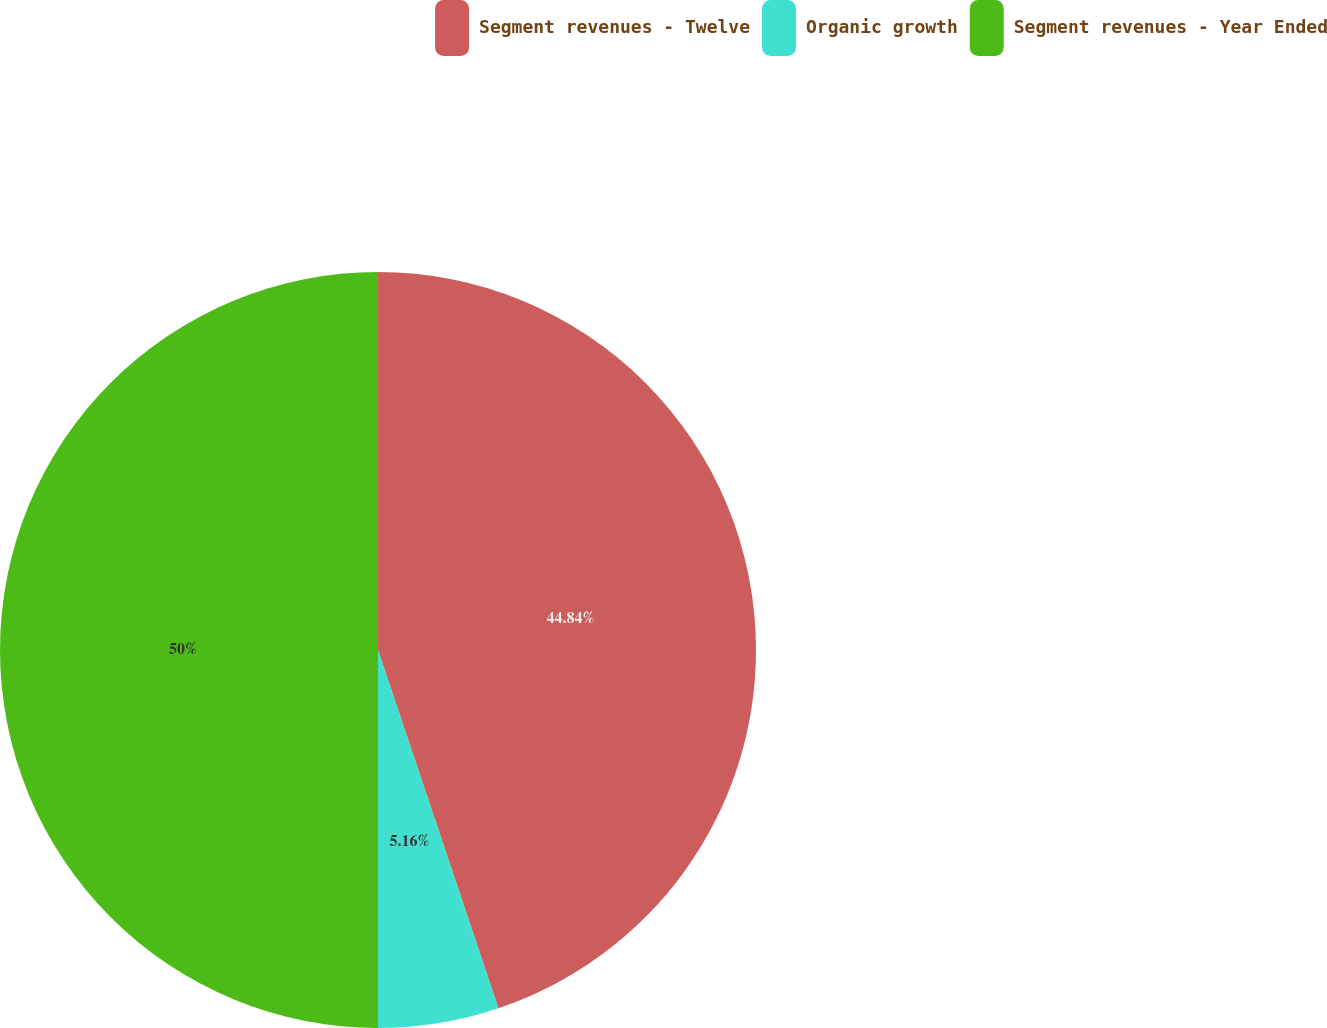Convert chart to OTSL. <chart><loc_0><loc_0><loc_500><loc_500><pie_chart><fcel>Segment revenues - Twelve<fcel>Organic growth<fcel>Segment revenues - Year Ended<nl><fcel>44.84%<fcel>5.16%<fcel>50.0%<nl></chart> 